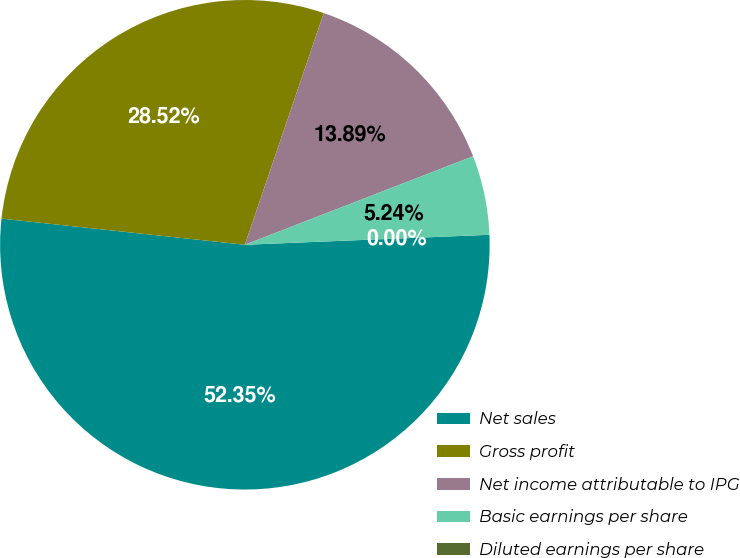<chart> <loc_0><loc_0><loc_500><loc_500><pie_chart><fcel>Net sales<fcel>Gross profit<fcel>Net income attributable to IPG<fcel>Basic earnings per share<fcel>Diluted earnings per share<nl><fcel>52.36%<fcel>28.52%<fcel>13.89%<fcel>5.24%<fcel>0.0%<nl></chart> 